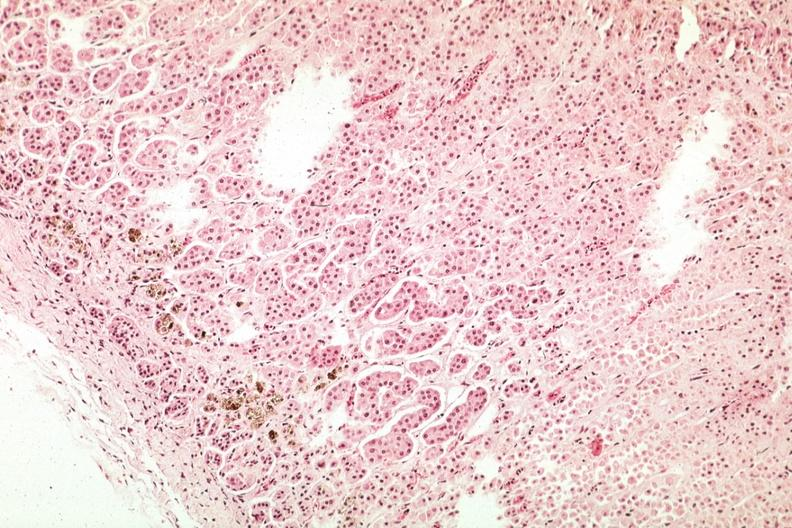s adrenal present?
Answer the question using a single word or phrase. Yes 